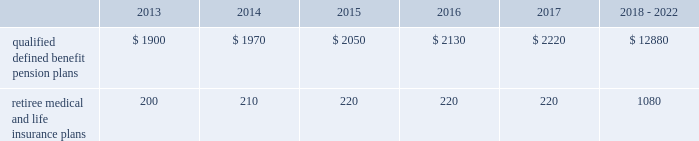Valuation techniques 2013 cash equivalents are mostly comprised of short-term money-market instruments and are valued at cost , which approximates fair value .
U.s .
Equity securities and international equity securities categorized as level 1 are traded on active national and international exchanges and are valued at their closing prices on the last trading day of the year .
For u.s .
Equity securities and international equity securities not traded on an active exchange , or if the closing price is not available , the trustee obtains indicative quotes from a pricing vendor , broker , or investment manager .
These securities are categorized as level 2 if the custodian obtains corroborated quotes from a pricing vendor or categorized as level 3 if the custodian obtains uncorroborated quotes from a broker or investment manager .
Commingled equity funds are public investment vehicles valued using the net asset value ( nav ) provided by the fund manager .
The nav is the total value of the fund divided by the number of shares outstanding .
Commingled equity funds are categorized as level 1 if traded at their nav on a nationally recognized securities exchange or categorized as level 2 if the nav is corroborated by observable market data ( e.g. , purchases or sales activity ) .
Fixed income securities categorized as level 2 are valued by the trustee using pricing models that use verifiable observable market data ( e.g .
Interest rates and yield curves observable at commonly quoted intervals ) , bids provided by brokers or dealers , or quoted prices of securities with similar characteristics .
Private equity funds , real estate funds , hedge funds , and fixed income securities categorized as level 3 are valued based on valuation models that include significant unobservable inputs and cannot be corroborated using verifiable observable market data .
Valuations for private equity funds and real estate funds are determined by the general partners , while hedge funds are valued by independent administrators .
Depending on the nature of the assets , the general partners or independent administrators use both the income and market approaches in their models .
The market approach consists of analyzing market transactions for comparable assets while the income approach uses earnings or the net present value of estimated future cash flows adjusted for liquidity and other risk factors .
Commodities categorized as level 1 are traded on an active commodity exchange and are valued at their closing prices on the last trading day of the year .
Commodities categorized as level 2 represent shares in a commingled commodity fund valued using the nav , which is corroborated by observable market data .
Contributions and expected benefit payments we generally determine funding requirements for our defined benefit pension plans in a manner consistent with cas and internal revenue code rules .
In 2012 , we made contributions of $ 3.6 billion related to our qualified defined benefit pension plans .
We plan to make contributions of approximately $ 1.5 billion related to the qualified defined benefit pension plans in 2013 .
In 2012 , we made contributions of $ 235 million related to our retiree medical and life insurance plans .
We expect no required contributions related to the retiree medical and life insurance plans in 2013 .
The table presents estimated future benefit payments , which reflect expected future employee service , as of december 31 , 2012 ( in millions ) : .
Defined contribution plans we maintain a number of defined contribution plans , most with 401 ( k ) features , that cover substantially all of our employees .
Under the provisions of our 401 ( k ) plans , we match most employees 2019 eligible contributions at rates specified in the plan documents .
Our contributions were $ 380 million in 2012 , $ 378 million in 2011 , and $ 379 million in 2010 , the majority of which were funded in our common stock .
Our defined contribution plans held approximately 48.6 million and 52.1 million shares of our common stock as of december 31 , 2012 and 2011. .
What is the percentage change in common stock held by defined contribution plans from 2011 to 2012? 
Computations: ((48.6 - 52.1) / 52.1)
Answer: -0.06718. 